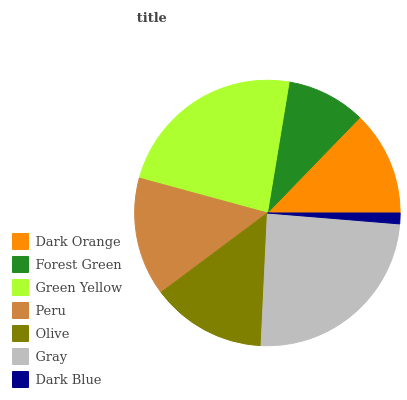Is Dark Blue the minimum?
Answer yes or no. Yes. Is Gray the maximum?
Answer yes or no. Yes. Is Forest Green the minimum?
Answer yes or no. No. Is Forest Green the maximum?
Answer yes or no. No. Is Dark Orange greater than Forest Green?
Answer yes or no. Yes. Is Forest Green less than Dark Orange?
Answer yes or no. Yes. Is Forest Green greater than Dark Orange?
Answer yes or no. No. Is Dark Orange less than Forest Green?
Answer yes or no. No. Is Olive the high median?
Answer yes or no. Yes. Is Olive the low median?
Answer yes or no. Yes. Is Dark Blue the high median?
Answer yes or no. No. Is Forest Green the low median?
Answer yes or no. No. 